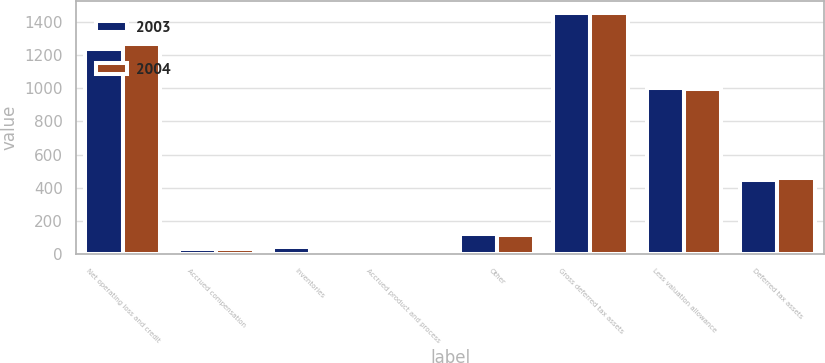<chart> <loc_0><loc_0><loc_500><loc_500><stacked_bar_chart><ecel><fcel>Net operating loss and credit<fcel>Accrued compensation<fcel>Inventories<fcel>Accrued product and process<fcel>Other<fcel>Gross deferred tax assets<fcel>Less valuation allowance<fcel>Deferred tax assets<nl><fcel>2003<fcel>1237.7<fcel>33.9<fcel>46.3<fcel>11.2<fcel>122.7<fcel>1451.8<fcel>1004.3<fcel>447.5<nl><fcel>2004<fcel>1263.9<fcel>31.2<fcel>25.2<fcel>14.6<fcel>116<fcel>1450.9<fcel>993.1<fcel>457.8<nl></chart> 